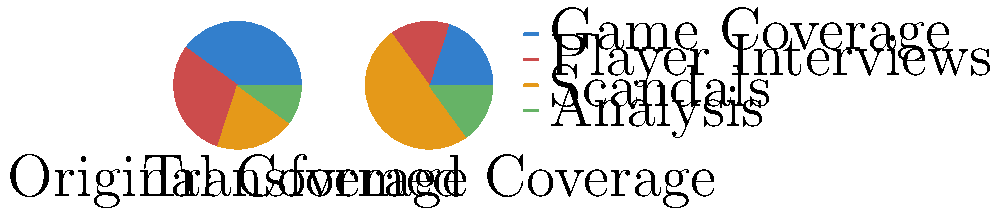The pie charts show the distribution of sports coverage before and after a transformation. If the transformation involves rotating the original chart by 90° clockwise and then dilating the "Scandals" sector by a scale factor of 2.5, what is the percentage increase in the area devoted to scandals in the transformed chart compared to the original? To solve this problem, we need to follow these steps:

1. Identify the original percentage for scandals:
   In the original chart, scandals occupy 20% of the total area.

2. Calculate the new percentage for scandals after transformation:
   After dilation by a scale factor of 2.5, the scandals sector becomes:
   $20\% \times 2.5 = 50\%$ of the total area in the transformed chart.

3. Calculate the percentage increase:
   Percentage increase = $\frac{\text{New Value} - \text{Original Value}}{\text{Original Value}} \times 100\%$
   
   $\text{Percentage increase} = \frac{50\% - 20\%}{20\%} \times 100\%$
   
   $= \frac{30\%}{20\%} \times 100\%$
   
   $= 1.5 \times 100\%$
   
   $= 150\%$

Therefore, the percentage increase in the area devoted to scandals is 150%.
Answer: 150% 